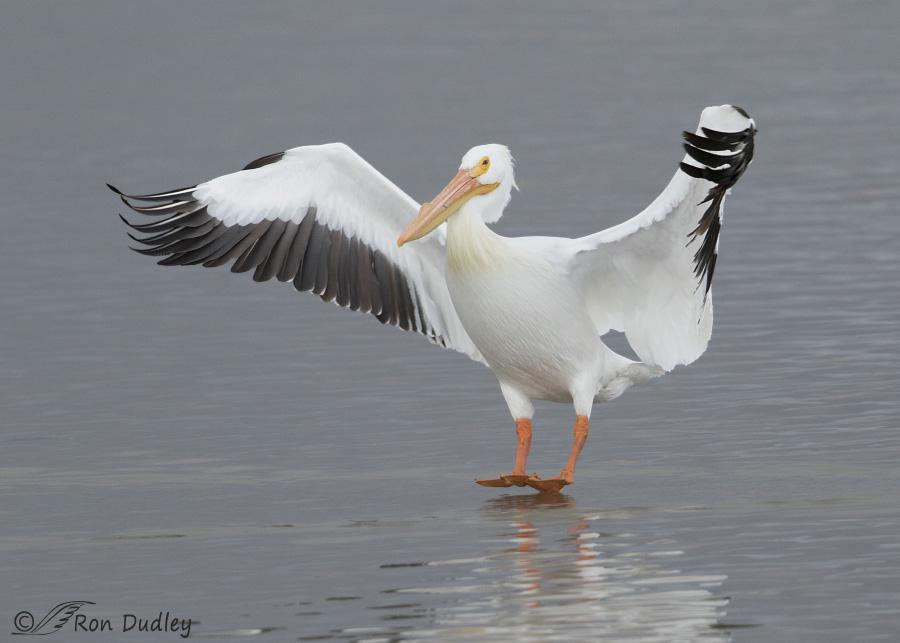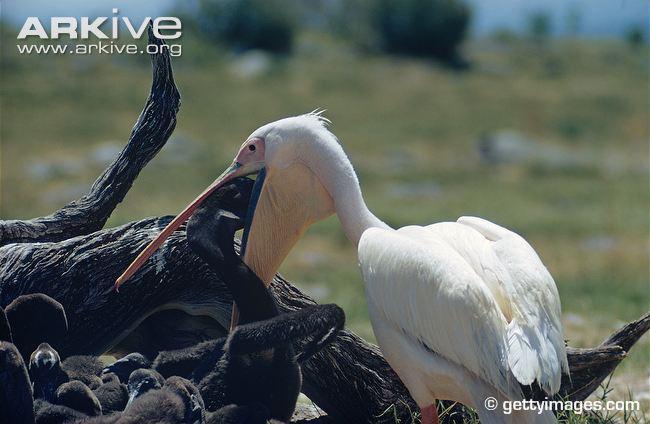The first image is the image on the left, the second image is the image on the right. Assess this claim about the two images: "One of the birds is spreading its wings.". Correct or not? Answer yes or no. Yes. The first image is the image on the left, the second image is the image on the right. Given the left and right images, does the statement "The left image contains at least two large birds at a beach." hold true? Answer yes or no. No. 